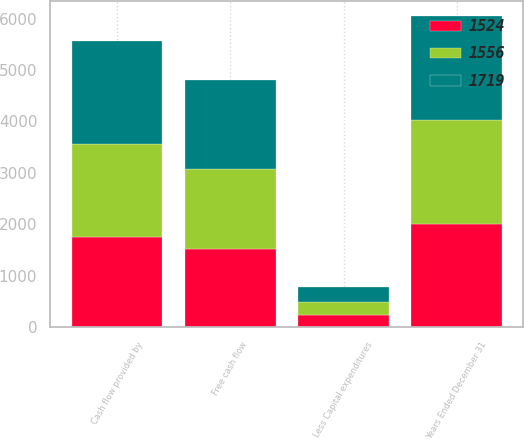<chart> <loc_0><loc_0><loc_500><loc_500><stacked_bar_chart><ecel><fcel>Years Ended December 31<fcel>Cash flow provided by<fcel>Less Capital expenditures<fcel>Free cash flow<nl><fcel>1719<fcel>2015<fcel>2009<fcel>290<fcel>1719<nl><fcel>1556<fcel>2014<fcel>1812<fcel>256<fcel>1556<nl><fcel>1524<fcel>2013<fcel>1753<fcel>229<fcel>1524<nl></chart> 